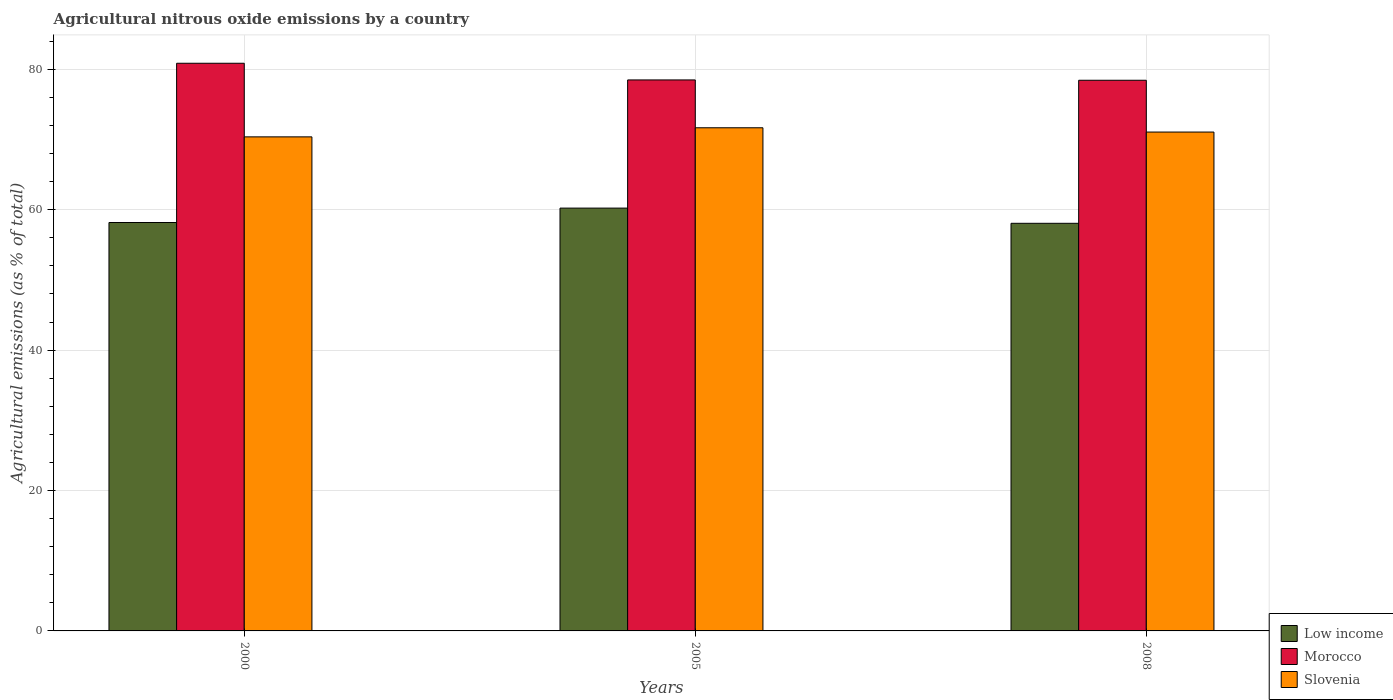How many different coloured bars are there?
Offer a very short reply. 3. How many groups of bars are there?
Give a very brief answer. 3. How many bars are there on the 2nd tick from the left?
Make the answer very short. 3. How many bars are there on the 3rd tick from the right?
Offer a terse response. 3. In how many cases, is the number of bars for a given year not equal to the number of legend labels?
Your response must be concise. 0. What is the amount of agricultural nitrous oxide emitted in Low income in 2005?
Ensure brevity in your answer.  60.22. Across all years, what is the maximum amount of agricultural nitrous oxide emitted in Low income?
Make the answer very short. 60.22. Across all years, what is the minimum amount of agricultural nitrous oxide emitted in Low income?
Make the answer very short. 58.06. What is the total amount of agricultural nitrous oxide emitted in Slovenia in the graph?
Your response must be concise. 213.09. What is the difference between the amount of agricultural nitrous oxide emitted in Morocco in 2005 and that in 2008?
Offer a terse response. 0.05. What is the difference between the amount of agricultural nitrous oxide emitted in Morocco in 2008 and the amount of agricultural nitrous oxide emitted in Low income in 2005?
Offer a very short reply. 18.21. What is the average amount of agricultural nitrous oxide emitted in Low income per year?
Your answer should be very brief. 58.82. In the year 2005, what is the difference between the amount of agricultural nitrous oxide emitted in Morocco and amount of agricultural nitrous oxide emitted in Low income?
Make the answer very short. 18.26. In how many years, is the amount of agricultural nitrous oxide emitted in Low income greater than 8 %?
Your answer should be very brief. 3. What is the ratio of the amount of agricultural nitrous oxide emitted in Low income in 2000 to that in 2005?
Give a very brief answer. 0.97. Is the difference between the amount of agricultural nitrous oxide emitted in Morocco in 2005 and 2008 greater than the difference between the amount of agricultural nitrous oxide emitted in Low income in 2005 and 2008?
Provide a succinct answer. No. What is the difference between the highest and the second highest amount of agricultural nitrous oxide emitted in Low income?
Ensure brevity in your answer.  2.05. What is the difference between the highest and the lowest amount of agricultural nitrous oxide emitted in Morocco?
Make the answer very short. 2.42. In how many years, is the amount of agricultural nitrous oxide emitted in Low income greater than the average amount of agricultural nitrous oxide emitted in Low income taken over all years?
Offer a very short reply. 1. Is the sum of the amount of agricultural nitrous oxide emitted in Low income in 2000 and 2008 greater than the maximum amount of agricultural nitrous oxide emitted in Slovenia across all years?
Give a very brief answer. Yes. What does the 3rd bar from the left in 2008 represents?
Offer a very short reply. Slovenia. What does the 2nd bar from the right in 2000 represents?
Offer a terse response. Morocco. Is it the case that in every year, the sum of the amount of agricultural nitrous oxide emitted in Slovenia and amount of agricultural nitrous oxide emitted in Low income is greater than the amount of agricultural nitrous oxide emitted in Morocco?
Make the answer very short. Yes. Are the values on the major ticks of Y-axis written in scientific E-notation?
Make the answer very short. No. Does the graph contain any zero values?
Give a very brief answer. No. How many legend labels are there?
Provide a short and direct response. 3. What is the title of the graph?
Your response must be concise. Agricultural nitrous oxide emissions by a country. Does "Least developed countries" appear as one of the legend labels in the graph?
Offer a very short reply. No. What is the label or title of the Y-axis?
Keep it short and to the point. Agricultural emissions (as % of total). What is the Agricultural emissions (as % of total) in Low income in 2000?
Give a very brief answer. 58.17. What is the Agricultural emissions (as % of total) of Morocco in 2000?
Provide a succinct answer. 80.86. What is the Agricultural emissions (as % of total) of Slovenia in 2000?
Your answer should be very brief. 70.37. What is the Agricultural emissions (as % of total) in Low income in 2005?
Offer a very short reply. 60.22. What is the Agricultural emissions (as % of total) of Morocco in 2005?
Ensure brevity in your answer.  78.48. What is the Agricultural emissions (as % of total) in Slovenia in 2005?
Offer a terse response. 71.67. What is the Agricultural emissions (as % of total) of Low income in 2008?
Provide a succinct answer. 58.06. What is the Agricultural emissions (as % of total) in Morocco in 2008?
Give a very brief answer. 78.43. What is the Agricultural emissions (as % of total) in Slovenia in 2008?
Your answer should be very brief. 71.06. Across all years, what is the maximum Agricultural emissions (as % of total) of Low income?
Provide a succinct answer. 60.22. Across all years, what is the maximum Agricultural emissions (as % of total) in Morocco?
Give a very brief answer. 80.86. Across all years, what is the maximum Agricultural emissions (as % of total) of Slovenia?
Offer a very short reply. 71.67. Across all years, what is the minimum Agricultural emissions (as % of total) of Low income?
Make the answer very short. 58.06. Across all years, what is the minimum Agricultural emissions (as % of total) of Morocco?
Provide a succinct answer. 78.43. Across all years, what is the minimum Agricultural emissions (as % of total) in Slovenia?
Provide a succinct answer. 70.37. What is the total Agricultural emissions (as % of total) of Low income in the graph?
Your answer should be compact. 176.46. What is the total Agricultural emissions (as % of total) of Morocco in the graph?
Provide a succinct answer. 237.77. What is the total Agricultural emissions (as % of total) of Slovenia in the graph?
Offer a very short reply. 213.09. What is the difference between the Agricultural emissions (as % of total) of Low income in 2000 and that in 2005?
Your response must be concise. -2.05. What is the difference between the Agricultural emissions (as % of total) of Morocco in 2000 and that in 2005?
Ensure brevity in your answer.  2.37. What is the difference between the Agricultural emissions (as % of total) of Slovenia in 2000 and that in 2005?
Give a very brief answer. -1.29. What is the difference between the Agricultural emissions (as % of total) in Low income in 2000 and that in 2008?
Offer a very short reply. 0.11. What is the difference between the Agricultural emissions (as % of total) of Morocco in 2000 and that in 2008?
Your response must be concise. 2.42. What is the difference between the Agricultural emissions (as % of total) of Slovenia in 2000 and that in 2008?
Give a very brief answer. -0.68. What is the difference between the Agricultural emissions (as % of total) of Low income in 2005 and that in 2008?
Provide a succinct answer. 2.16. What is the difference between the Agricultural emissions (as % of total) of Morocco in 2005 and that in 2008?
Offer a terse response. 0.05. What is the difference between the Agricultural emissions (as % of total) in Slovenia in 2005 and that in 2008?
Make the answer very short. 0.61. What is the difference between the Agricultural emissions (as % of total) in Low income in 2000 and the Agricultural emissions (as % of total) in Morocco in 2005?
Your response must be concise. -20.31. What is the difference between the Agricultural emissions (as % of total) in Low income in 2000 and the Agricultural emissions (as % of total) in Slovenia in 2005?
Ensure brevity in your answer.  -13.49. What is the difference between the Agricultural emissions (as % of total) in Morocco in 2000 and the Agricultural emissions (as % of total) in Slovenia in 2005?
Keep it short and to the point. 9.19. What is the difference between the Agricultural emissions (as % of total) of Low income in 2000 and the Agricultural emissions (as % of total) of Morocco in 2008?
Make the answer very short. -20.26. What is the difference between the Agricultural emissions (as % of total) in Low income in 2000 and the Agricultural emissions (as % of total) in Slovenia in 2008?
Offer a very short reply. -12.88. What is the difference between the Agricultural emissions (as % of total) in Morocco in 2000 and the Agricultural emissions (as % of total) in Slovenia in 2008?
Ensure brevity in your answer.  9.8. What is the difference between the Agricultural emissions (as % of total) of Low income in 2005 and the Agricultural emissions (as % of total) of Morocco in 2008?
Provide a succinct answer. -18.21. What is the difference between the Agricultural emissions (as % of total) of Low income in 2005 and the Agricultural emissions (as % of total) of Slovenia in 2008?
Your response must be concise. -10.83. What is the difference between the Agricultural emissions (as % of total) of Morocco in 2005 and the Agricultural emissions (as % of total) of Slovenia in 2008?
Keep it short and to the point. 7.42. What is the average Agricultural emissions (as % of total) in Low income per year?
Provide a short and direct response. 58.82. What is the average Agricultural emissions (as % of total) in Morocco per year?
Your answer should be compact. 79.26. What is the average Agricultural emissions (as % of total) in Slovenia per year?
Your response must be concise. 71.03. In the year 2000, what is the difference between the Agricultural emissions (as % of total) of Low income and Agricultural emissions (as % of total) of Morocco?
Provide a succinct answer. -22.68. In the year 2000, what is the difference between the Agricultural emissions (as % of total) of Low income and Agricultural emissions (as % of total) of Slovenia?
Provide a succinct answer. -12.2. In the year 2000, what is the difference between the Agricultural emissions (as % of total) of Morocco and Agricultural emissions (as % of total) of Slovenia?
Give a very brief answer. 10.48. In the year 2005, what is the difference between the Agricultural emissions (as % of total) of Low income and Agricultural emissions (as % of total) of Morocco?
Make the answer very short. -18.26. In the year 2005, what is the difference between the Agricultural emissions (as % of total) of Low income and Agricultural emissions (as % of total) of Slovenia?
Provide a short and direct response. -11.44. In the year 2005, what is the difference between the Agricultural emissions (as % of total) in Morocco and Agricultural emissions (as % of total) in Slovenia?
Provide a short and direct response. 6.82. In the year 2008, what is the difference between the Agricultural emissions (as % of total) in Low income and Agricultural emissions (as % of total) in Morocco?
Provide a succinct answer. -20.37. In the year 2008, what is the difference between the Agricultural emissions (as % of total) in Low income and Agricultural emissions (as % of total) in Slovenia?
Ensure brevity in your answer.  -13. In the year 2008, what is the difference between the Agricultural emissions (as % of total) in Morocco and Agricultural emissions (as % of total) in Slovenia?
Ensure brevity in your answer.  7.38. What is the ratio of the Agricultural emissions (as % of total) in Low income in 2000 to that in 2005?
Give a very brief answer. 0.97. What is the ratio of the Agricultural emissions (as % of total) in Morocco in 2000 to that in 2005?
Offer a very short reply. 1.03. What is the ratio of the Agricultural emissions (as % of total) of Slovenia in 2000 to that in 2005?
Ensure brevity in your answer.  0.98. What is the ratio of the Agricultural emissions (as % of total) of Low income in 2000 to that in 2008?
Provide a succinct answer. 1. What is the ratio of the Agricultural emissions (as % of total) in Morocco in 2000 to that in 2008?
Keep it short and to the point. 1.03. What is the ratio of the Agricultural emissions (as % of total) in Slovenia in 2000 to that in 2008?
Provide a succinct answer. 0.99. What is the ratio of the Agricultural emissions (as % of total) in Low income in 2005 to that in 2008?
Your response must be concise. 1.04. What is the ratio of the Agricultural emissions (as % of total) of Morocco in 2005 to that in 2008?
Provide a succinct answer. 1. What is the ratio of the Agricultural emissions (as % of total) of Slovenia in 2005 to that in 2008?
Your response must be concise. 1.01. What is the difference between the highest and the second highest Agricultural emissions (as % of total) of Low income?
Give a very brief answer. 2.05. What is the difference between the highest and the second highest Agricultural emissions (as % of total) of Morocco?
Offer a very short reply. 2.37. What is the difference between the highest and the second highest Agricultural emissions (as % of total) of Slovenia?
Give a very brief answer. 0.61. What is the difference between the highest and the lowest Agricultural emissions (as % of total) of Low income?
Give a very brief answer. 2.16. What is the difference between the highest and the lowest Agricultural emissions (as % of total) of Morocco?
Your answer should be compact. 2.42. What is the difference between the highest and the lowest Agricultural emissions (as % of total) of Slovenia?
Offer a terse response. 1.29. 